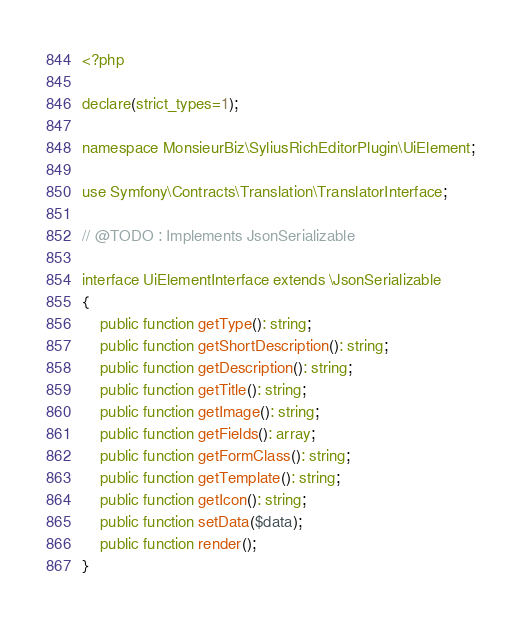<code> <loc_0><loc_0><loc_500><loc_500><_PHP_><?php

declare(strict_types=1);

namespace MonsieurBiz\SyliusRichEditorPlugin\UiElement;

use Symfony\Contracts\Translation\TranslatorInterface;

// @TODO : Implements JsonSerializable

interface UiElementInterface extends \JsonSerializable
{
    public function getType(): string;
    public function getShortDescription(): string;
    public function getDescription(): string;
    public function getTitle(): string;
    public function getImage(): string;
    public function getFields(): array;
    public function getFormClass(): string;
    public function getTemplate(): string;
    public function getIcon(): string;
    public function setData($data);
    public function render();
}
</code> 